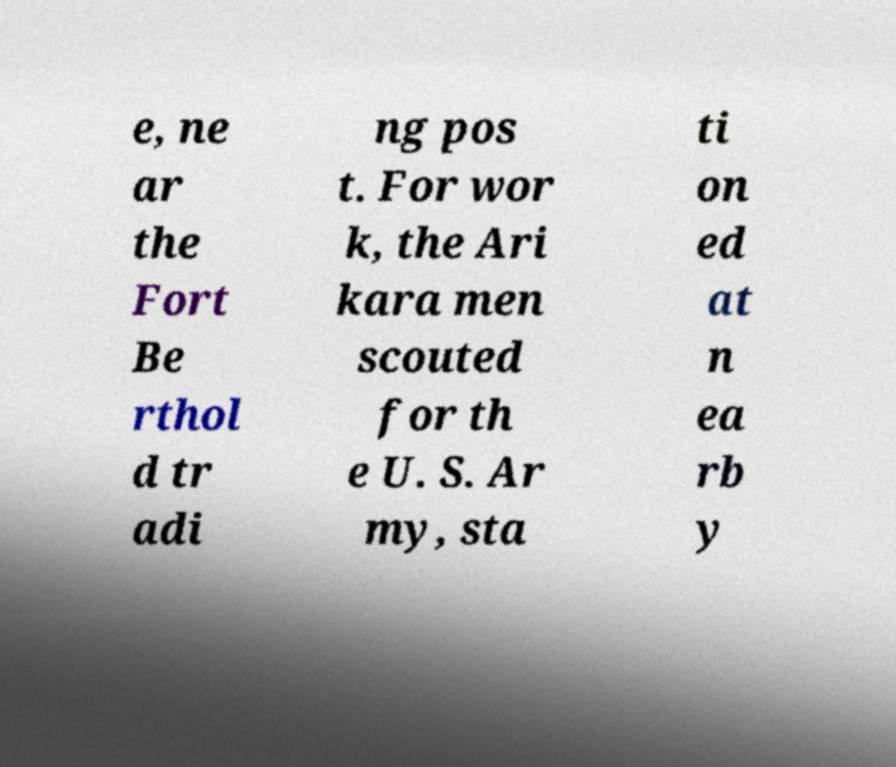Could you extract and type out the text from this image? e, ne ar the Fort Be rthol d tr adi ng pos t. For wor k, the Ari kara men scouted for th e U. S. Ar my, sta ti on ed at n ea rb y 